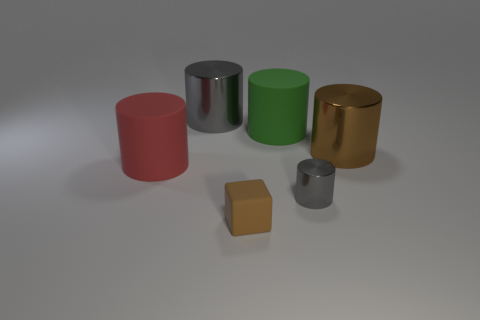Subtract all blue blocks. Subtract all red cylinders. How many blocks are left? 1 Add 4 large matte cylinders. How many objects exist? 10 Subtract all cubes. How many objects are left? 5 Add 1 brown shiny objects. How many brown shiny objects are left? 2 Add 4 big gray cylinders. How many big gray cylinders exist? 5 Subtract 0 yellow cylinders. How many objects are left? 6 Subtract all small gray cubes. Subtract all small cubes. How many objects are left? 5 